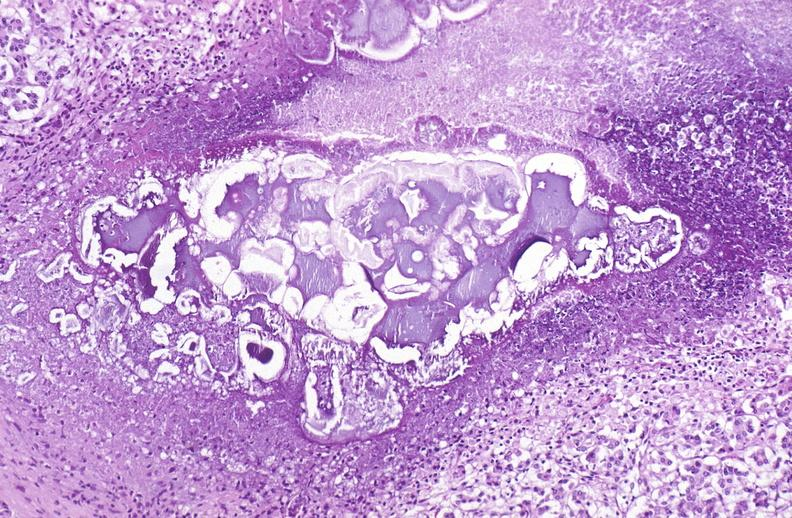where is this?
Answer the question using a single word or phrase. Pancreas 